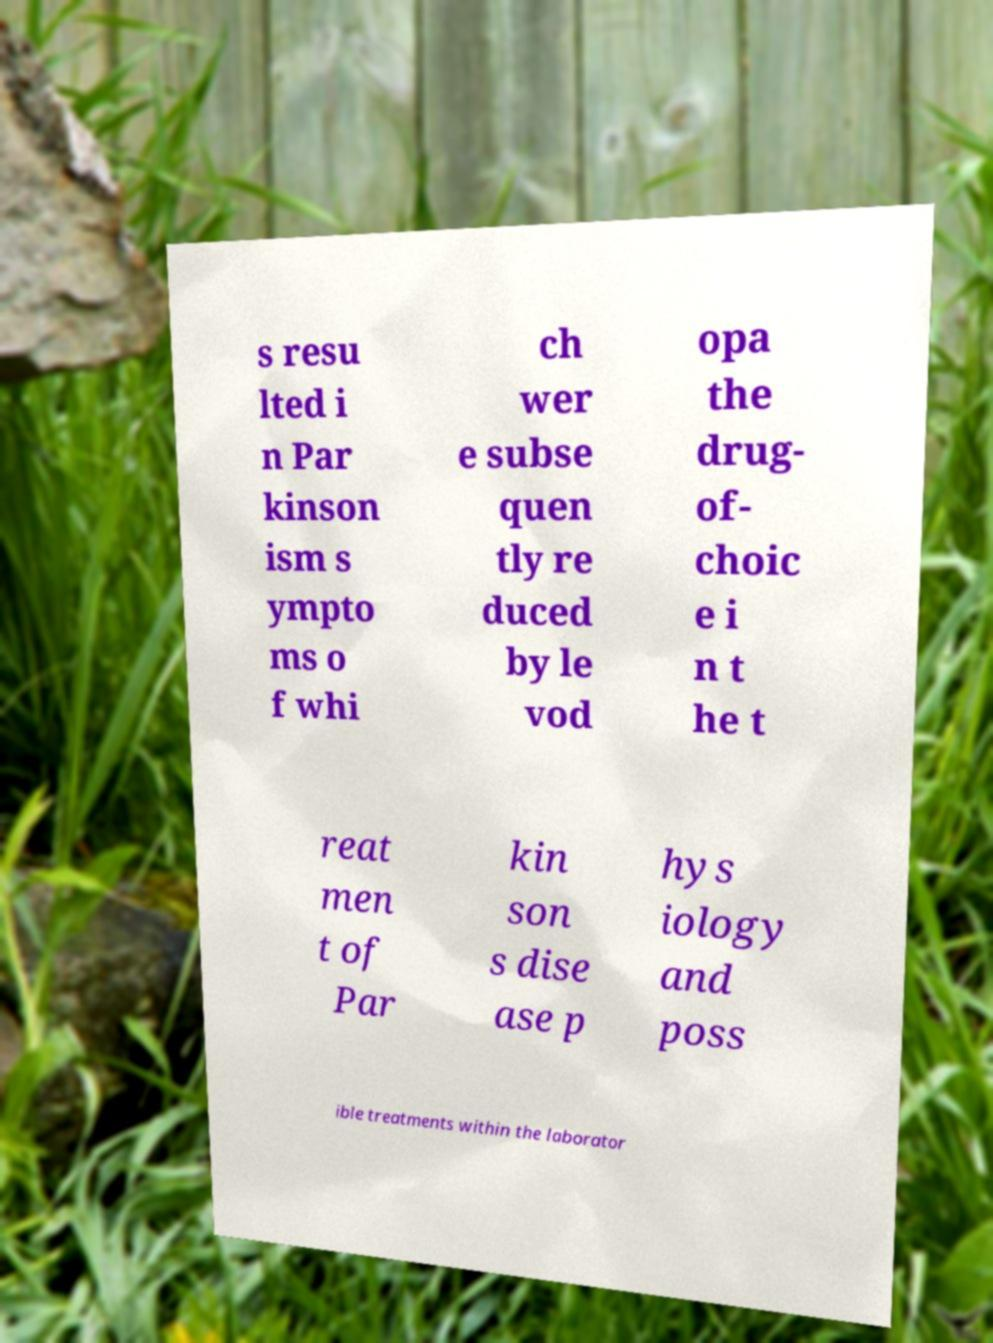For documentation purposes, I need the text within this image transcribed. Could you provide that? s resu lted i n Par kinson ism s ympto ms o f whi ch wer e subse quen tly re duced by le vod opa the drug- of- choic e i n t he t reat men t of Par kin son s dise ase p hys iology and poss ible treatments within the laborator 